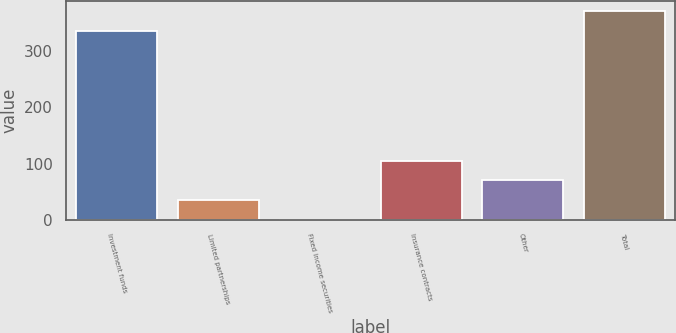Convert chart. <chart><loc_0><loc_0><loc_500><loc_500><bar_chart><fcel>Investment funds<fcel>Limited partnerships<fcel>Fixed income securities<fcel>Insurance contracts<fcel>Other<fcel>Total<nl><fcel>335.8<fcel>35.35<fcel>0.4<fcel>105.25<fcel>70.3<fcel>370.75<nl></chart> 